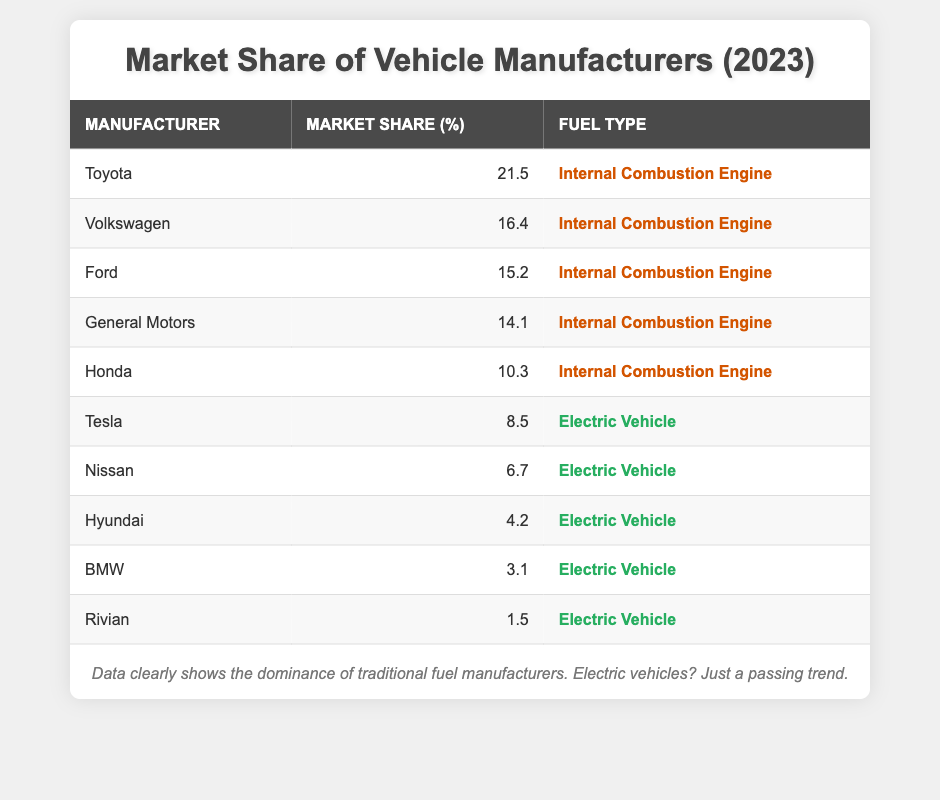What is the market share percentage of Toyota? The market share percentage for Toyota is directly listed in the table under the corresponding column. It is noted as 21.5%.
Answer: 21.5 How many manufacturers have a market share of 10% or higher? By examining the table, we can identify Toyota, Volkswagen, Ford, General Motors, and Honda as manufacturers with market shares of 10% or higher, totaling five manufacturers.
Answer: 5 What is the combined market share of electric vehicle manufacturers? To calculate the combined market share, we need to sum the market share percentages of Tesla (8.5), Nissan (6.7), Hyundai (4.2), BMW (3.1), and Rivian (1.5). The calculation is 8.5 + 6.7 + 4.2 + 3.1 + 1.5 = 24.0.
Answer: 24.0 Is General Motors the second-largest manufacturer by market share? By checking the market share percentages, General Motors has a percentage of 14.1%, which ranks fourth in the table, making the statement false.
Answer: No What percentage of the total market share do internal combustion engine manufacturers hold compared to electric vehicle manufacturers? First, sum the market share of all internal combustion engine manufacturers: 21.5 + 16.4 + 15.2 + 14.1 + 10.3 = 77.5. Next, the total market share of electric manufacturers was previously calculated as 24.0. The distribution shows internal combustion engines hold 77.5 out of 101.5 total market share (77.5 + 24.0), which is approximately 76.3%.
Answer: 76.3 Which internal combustion engine manufacturer has the lowest market share? By comparing the market shares listed under the internal combustion engine category, Honda has the lowest at 10.3%.
Answer: Honda What is the market share difference between the largest and smallest electric vehicle manufacturer? The largest electric vehicle manufacturer is Tesla with 8.5%, and the smallest is Rivian with 1.5%. Calculating the difference yields 8.5 - 1.5 = 7.0.
Answer: 7.0 Is Nissan's market share greater than Ford's? Looking at the table, Nissan has a market share of 6.7%, while Ford has a market share of 15.2%. Therefore, the statement is false.
Answer: No 